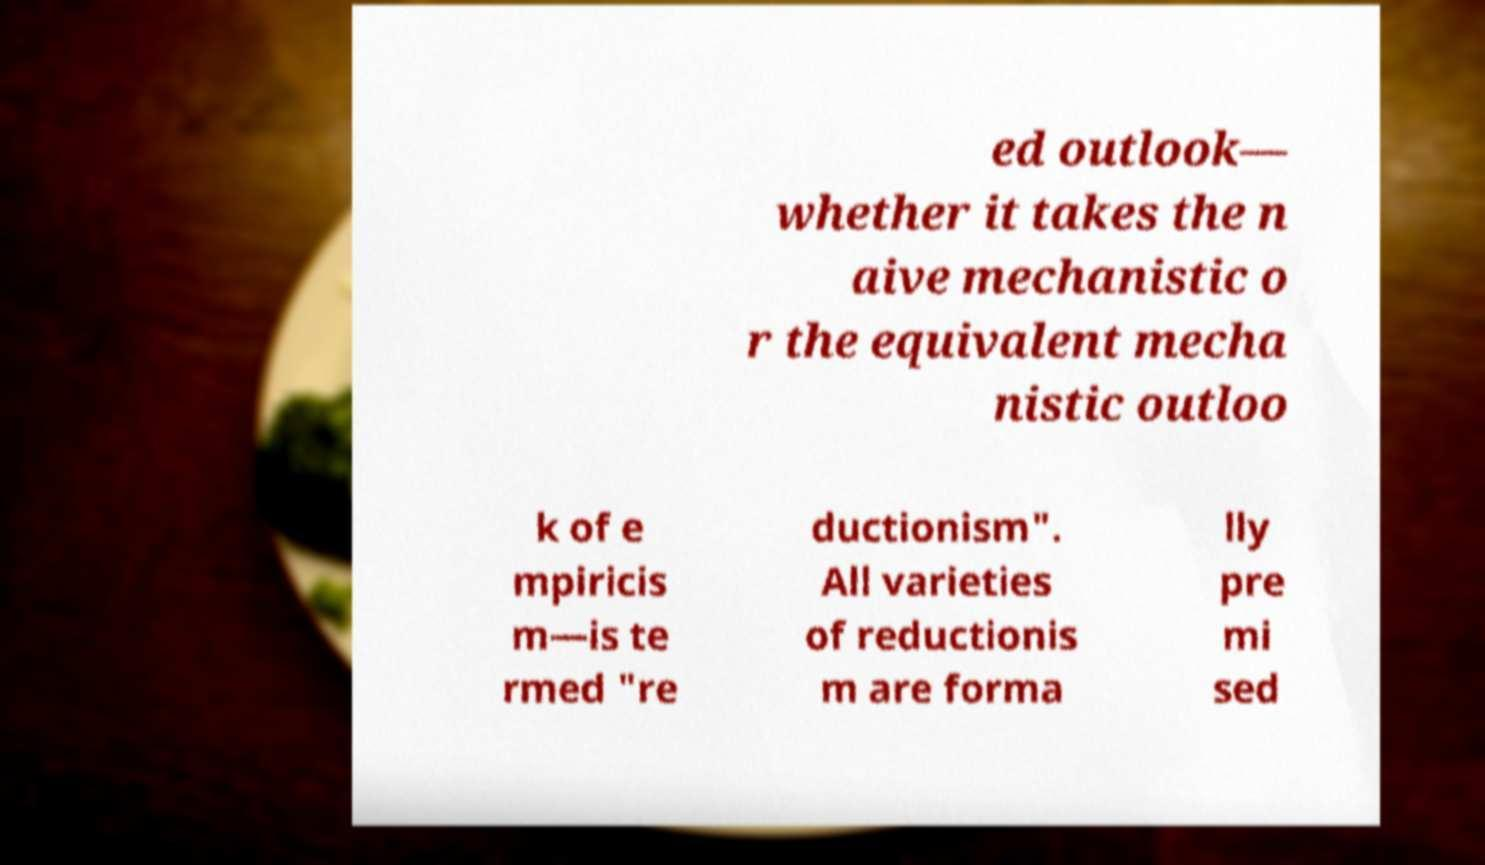For documentation purposes, I need the text within this image transcribed. Could you provide that? ed outlook— whether it takes the n aive mechanistic o r the equivalent mecha nistic outloo k of e mpiricis m—is te rmed "re ductionism". All varieties of reductionis m are forma lly pre mi sed 